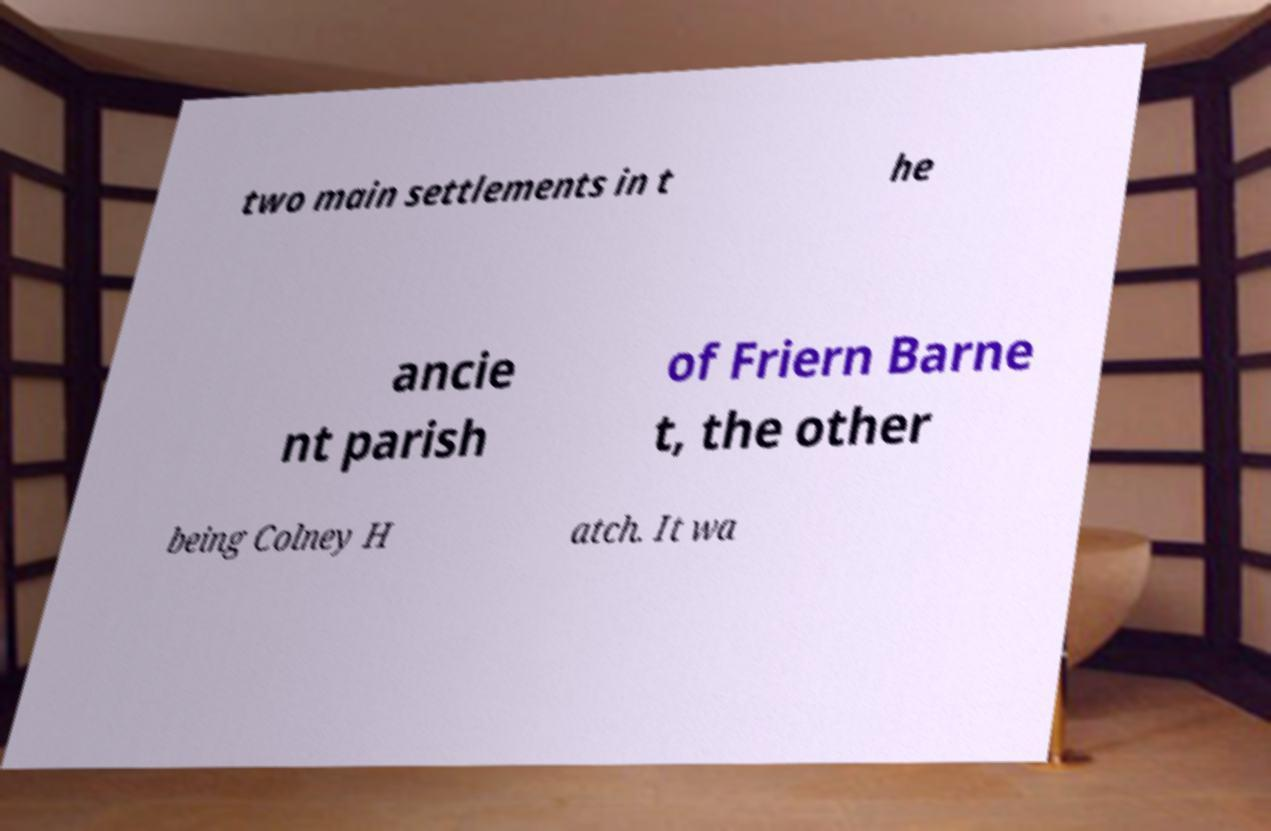Please identify and transcribe the text found in this image. two main settlements in t he ancie nt parish of Friern Barne t, the other being Colney H atch. It wa 